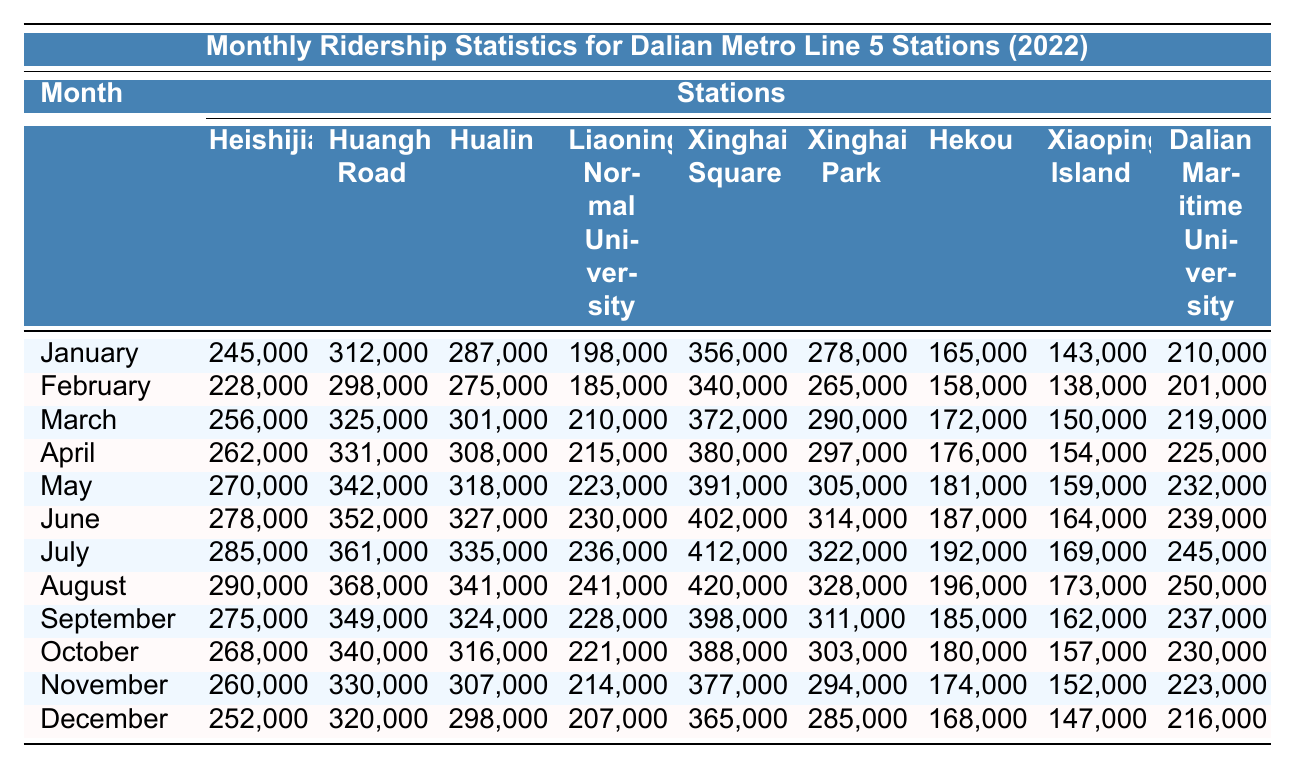What is the total ridership for Xinghai Square in July? The value for Xinghai Square in July is 412,000. To find the total, we simply refer to the table and use the number provided.
Answer: 412,000 Which station had the highest ridership in August? Looking at the data for August, we see that Xinghai Square has the highest ridership figure of 420,000.
Answer: Xinghai Square What was the average monthly ridership for Heishijiao throughout the year? The monthly ridership values for Heishijiao are: 245,000, 228,000, 256,000, 262,000, 270,000, 278,000, 285,000, 290,000, 275,000, 268,000, 260,000, and 252,000. Adding these gives 3,191,000, and dividing by 12 gives an average of approximately 266,000.
Answer: 266,000 Was the ridership for Hekou greater in January or November? In January, the ridership for Hekou is 165,000, while in November it is 174,000. Comparing the two values shows that November had higher ridership.
Answer: Yes How much did the ridership for Xiaoping Island increase from January to December? The value for Xiaoping Island in January is 143,000 and in December it is 147,000. The increase is calculated as 147,000 - 143,000, which equals 4,000.
Answer: 4,000 What was the total ridership across all stations in September? The monthly ridership figures for September are: 275,000 + 349,000 + 324,000 + 228,000 + 398,000 + 311,000 + 185,000 + 162,000 + 237,000. Calculating the sum gives a total of 2,363,000.
Answer: 2,363,000 Did any station have a ridership of over 300,000 in October? Reviewing the October figures, we see 340,000 (Huanghe Road), 316,000 (Hualin), 388,000 (Xinghai Square), and 303,000 (Xinghai Park) are all over 300,000. Therefore, the answer is yes.
Answer: Yes What is the difference in ridership between the highest and lowest station in May? In May, the highest ridership is 391,000 (Xinghai Square) and the lowest is 159,000 (Xiaoping Island). The difference is 391,000 - 159,000 = 232,000.
Answer: 232,000 Which month had the highest average ridership across all stations? To find the month with the highest average, it's necessary to calculate the average for each month. The calculations show that July, with an average of around 255,000, has the highest average ridership among all months.
Answer: July How did monthly ridership for Liaoning Normal University compare from January to December? The January value for Liaoning Normal University is 198,000 and December is 207,000. The comparison shows an increase, as December is higher than January.
Answer: Increased Which station consistently had the lowest ridership throughout the year? Observing the data across all months, Hekou shows the lowest ridership consistently, particularly in the numbers provided for January through December.
Answer: Hekou 